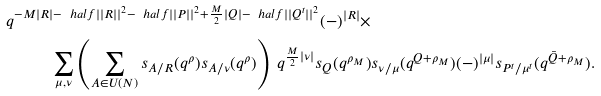Convert formula to latex. <formula><loc_0><loc_0><loc_500><loc_500>q ^ { - M | R | - \ h a l f | | R | | ^ { 2 } - \ h a l f | | P | | ^ { 2 } + \frac { M } { 2 } | Q | - \ h a l f | | Q ^ { t } | | ^ { 2 } } ( - ) ^ { | R | } \times & \\ \sum _ { \mu , \nu } \left ( \sum _ { A \in U ( N ) } s _ { A / R } ( q ^ { \rho } ) s _ { A / \nu } ( q ^ { \rho } ) \right ) \ q ^ { \frac { M } { 2 } | \nu | } s _ { Q } ( q ^ { \rho _ { M } } ) & s _ { \nu / \mu } ( q ^ { Q + \rho _ { M } } ) ( - ) ^ { | \mu | } s _ { P ^ { t } / \mu ^ { t } } ( q ^ { \bar { Q } + \rho _ { M } } ) .</formula> 